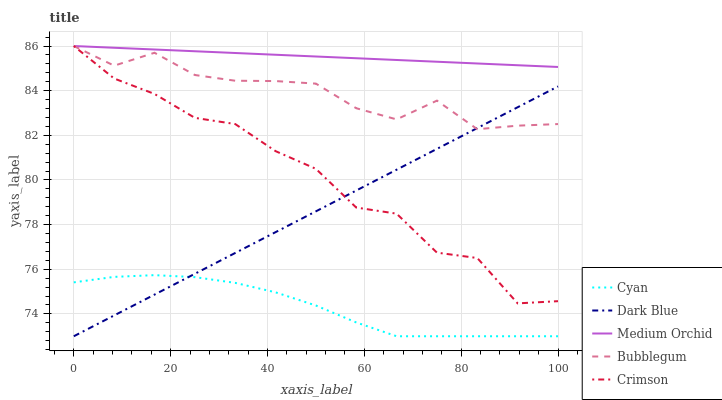Does Cyan have the minimum area under the curve?
Answer yes or no. Yes. Does Medium Orchid have the maximum area under the curve?
Answer yes or no. Yes. Does Medium Orchid have the minimum area under the curve?
Answer yes or no. No. Does Cyan have the maximum area under the curve?
Answer yes or no. No. Is Medium Orchid the smoothest?
Answer yes or no. Yes. Is Crimson the roughest?
Answer yes or no. Yes. Is Cyan the smoothest?
Answer yes or no. No. Is Cyan the roughest?
Answer yes or no. No. Does Cyan have the lowest value?
Answer yes or no. Yes. Does Medium Orchid have the lowest value?
Answer yes or no. No. Does Bubblegum have the highest value?
Answer yes or no. Yes. Does Cyan have the highest value?
Answer yes or no. No. Is Cyan less than Medium Orchid?
Answer yes or no. Yes. Is Medium Orchid greater than Dark Blue?
Answer yes or no. Yes. Does Cyan intersect Dark Blue?
Answer yes or no. Yes. Is Cyan less than Dark Blue?
Answer yes or no. No. Is Cyan greater than Dark Blue?
Answer yes or no. No. Does Cyan intersect Medium Orchid?
Answer yes or no. No. 